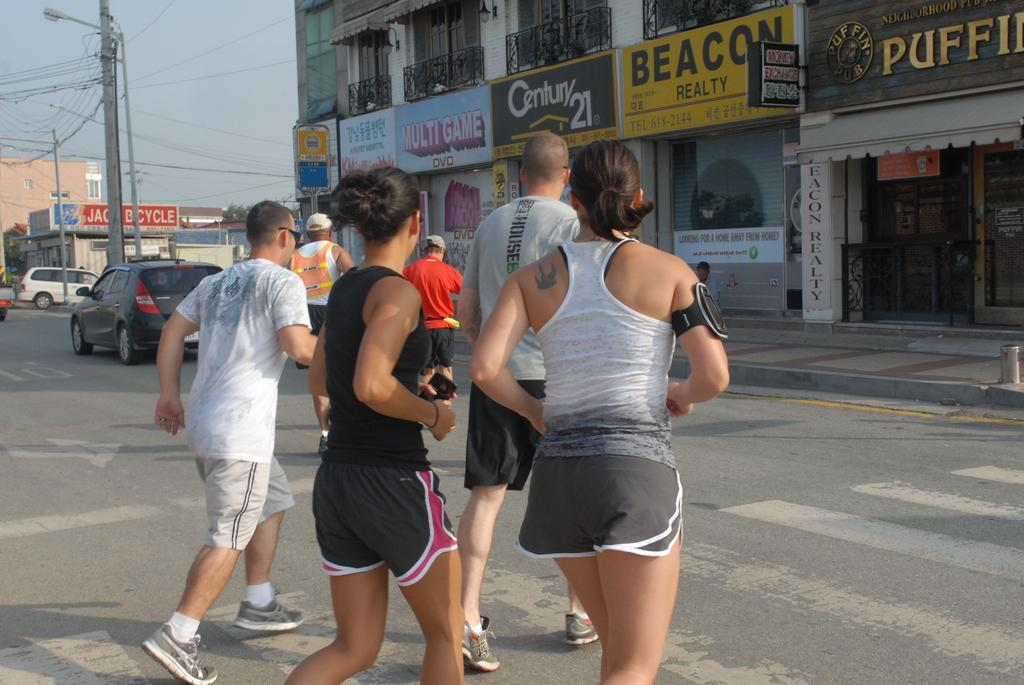<image>
Render a clear and concise summary of the photo. a group of runners going passed a century 21 sign 